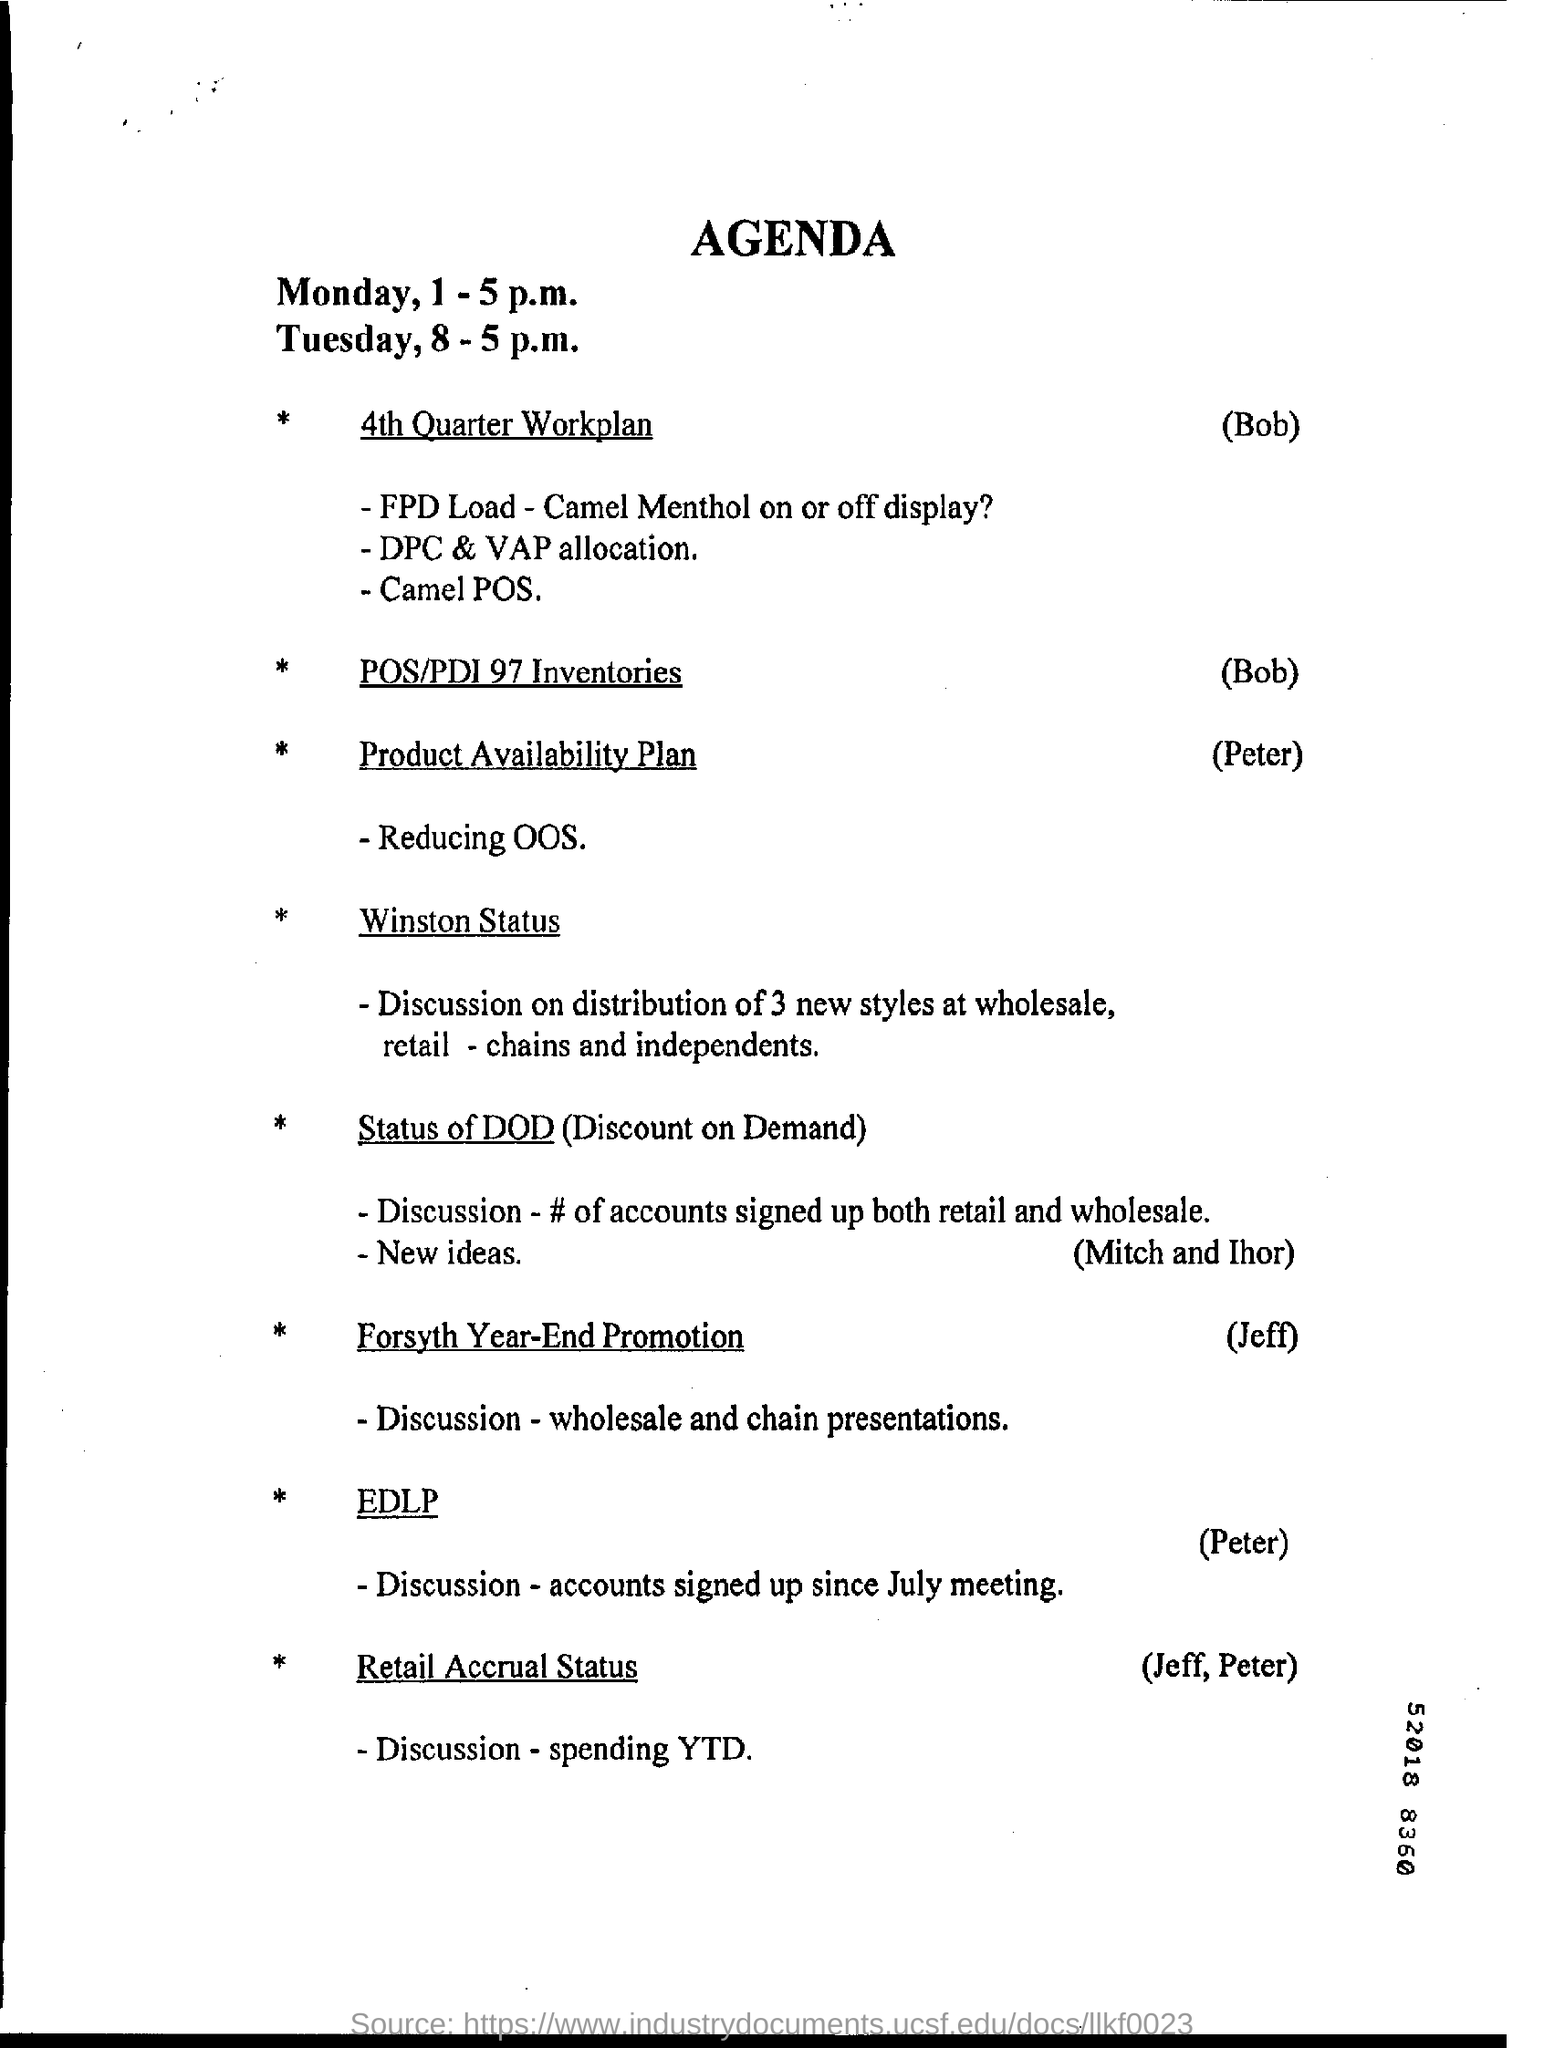Who will explain 4th Quarter workplan?
Offer a very short reply. Bob. What does DOD stand for?
Keep it short and to the point. Discount on Demand. 